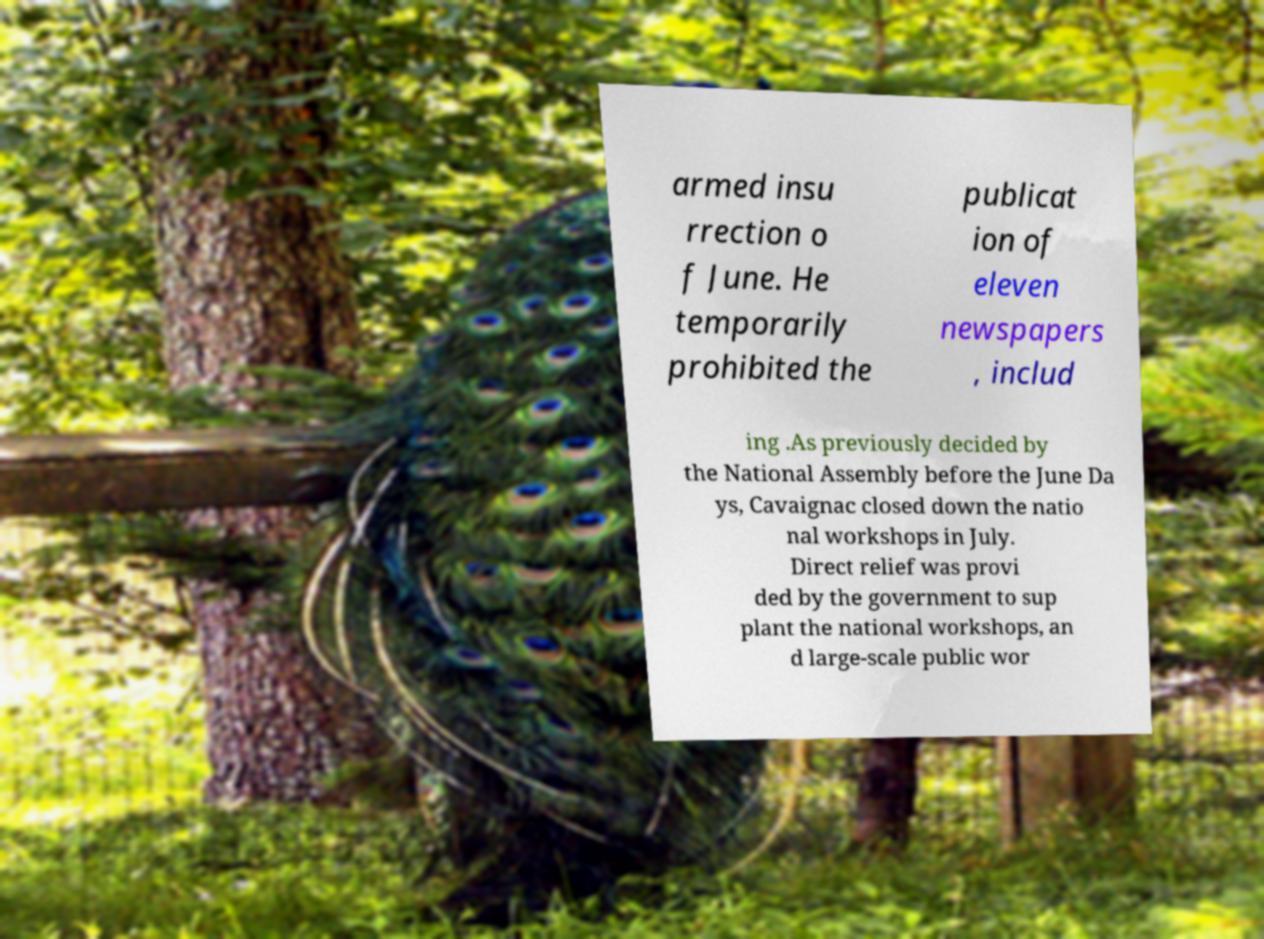Can you accurately transcribe the text from the provided image for me? armed insu rrection o f June. He temporarily prohibited the publicat ion of eleven newspapers , includ ing .As previously decided by the National Assembly before the June Da ys, Cavaignac closed down the natio nal workshops in July. Direct relief was provi ded by the government to sup plant the national workshops, an d large-scale public wor 